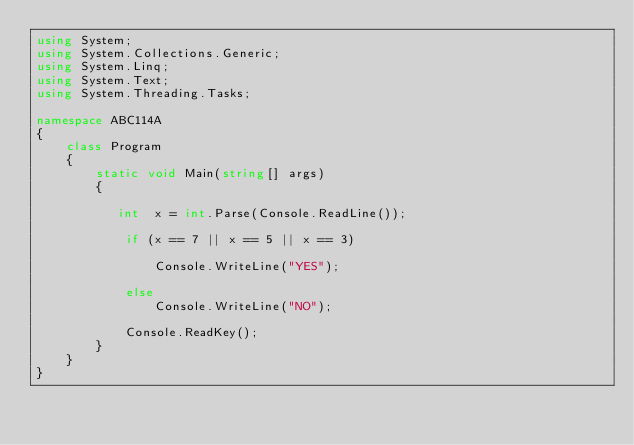<code> <loc_0><loc_0><loc_500><loc_500><_C#_>using System;
using System.Collections.Generic;
using System.Linq;
using System.Text;
using System.Threading.Tasks;

namespace ABC114A
{
    class Program
    {
        static void Main(string[] args)
        {
           
           int  x = int.Parse(Console.ReadLine());

            if (x == 7 || x == 5 || x == 3)

                Console.WriteLine("YES");

            else
                Console.WriteLine("NO");

            Console.ReadKey();
        }
    }
}

</code> 